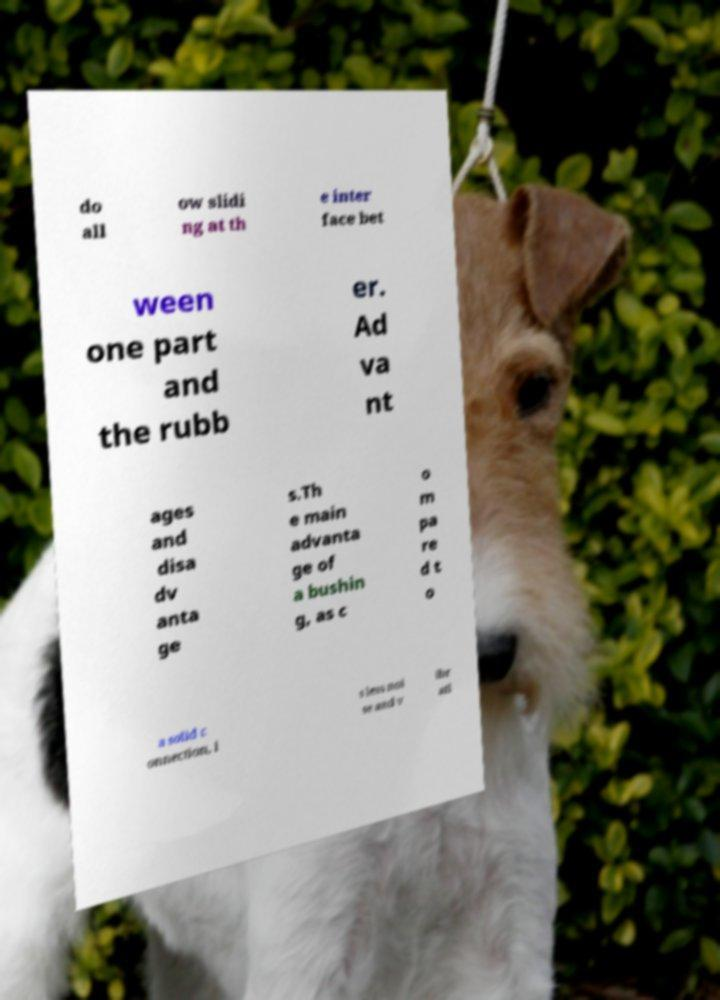Can you accurately transcribe the text from the provided image for me? do all ow slidi ng at th e inter face bet ween one part and the rubb er. Ad va nt ages and disa dv anta ge s.Th e main advanta ge of a bushin g, as c o m pa re d t o a solid c onnection, i s less noi se and v ibr ati 